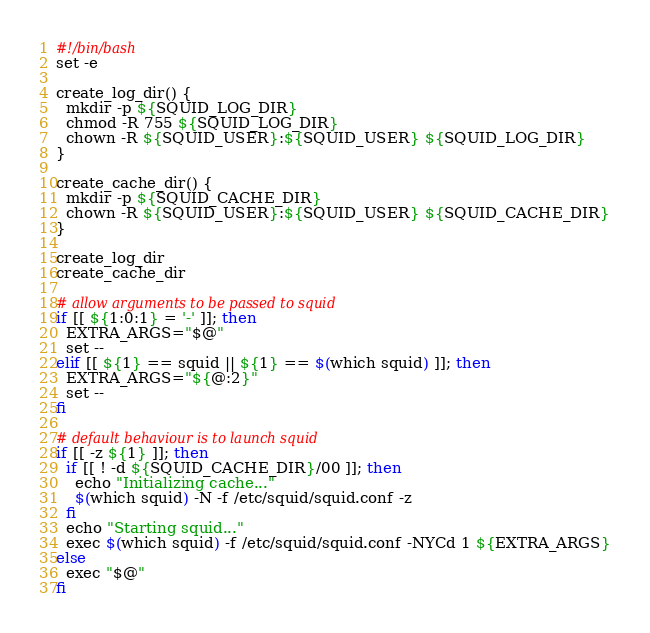<code> <loc_0><loc_0><loc_500><loc_500><_Bash_>#!/bin/bash
set -e

create_log_dir() {
  mkdir -p ${SQUID_LOG_DIR}
  chmod -R 755 ${SQUID_LOG_DIR}
  chown -R ${SQUID_USER}:${SQUID_USER} ${SQUID_LOG_DIR}
}

create_cache_dir() {
  mkdir -p ${SQUID_CACHE_DIR}
  chown -R ${SQUID_USER}:${SQUID_USER} ${SQUID_CACHE_DIR}
}

create_log_dir
create_cache_dir

# allow arguments to be passed to squid
if [[ ${1:0:1} = '-' ]]; then
  EXTRA_ARGS="$@"
  set --
elif [[ ${1} == squid || ${1} == $(which squid) ]]; then
  EXTRA_ARGS="${@:2}"
  set --
fi

# default behaviour is to launch squid
if [[ -z ${1} ]]; then
  if [[ ! -d ${SQUID_CACHE_DIR}/00 ]]; then
    echo "Initializing cache..."
    $(which squid) -N -f /etc/squid/squid.conf -z
  fi
  echo "Starting squid..."
  exec $(which squid) -f /etc/squid/squid.conf -NYCd 1 ${EXTRA_ARGS}
else
  exec "$@"
fi
</code> 